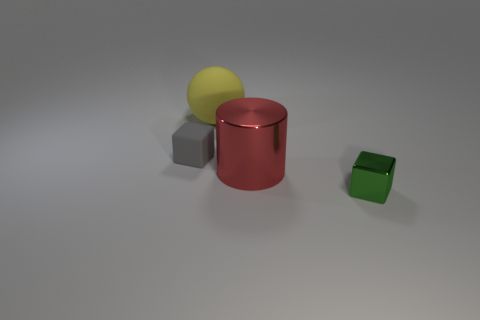What is the color of the other small object that is the same shape as the tiny gray rubber thing?
Keep it short and to the point. Green. What size is the matte object that is the same shape as the green metallic object?
Provide a succinct answer. Small. Are there any yellow rubber things that have the same size as the gray rubber thing?
Provide a short and direct response. No. There is a cube that is left of the large sphere; is its color the same as the big metal object that is behind the small metallic cube?
Your answer should be very brief. No. Are there any metal things of the same color as the sphere?
Your answer should be very brief. No. How many other objects are there of the same shape as the yellow object?
Your answer should be compact. 0. What is the shape of the small thing that is on the left side of the green shiny object?
Your answer should be very brief. Cube. Is the shape of the green thing the same as the small object left of the large red metal cylinder?
Provide a short and direct response. Yes. There is a object that is left of the big red metal thing and on the right side of the tiny gray block; what size is it?
Your answer should be very brief. Large. What is the color of the thing that is both behind the red metallic thing and in front of the yellow object?
Your answer should be very brief. Gray. 